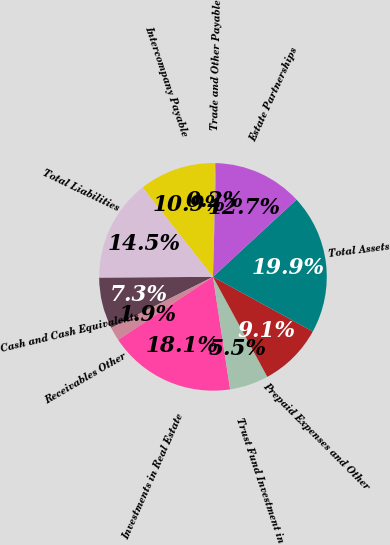Convert chart. <chart><loc_0><loc_0><loc_500><loc_500><pie_chart><fcel>Cash and Cash Equivalents<fcel>Receivables Other<fcel>Investments in Real Estate<fcel>Trust Fund Investment in<fcel>Prepaid Expenses and Other<fcel>Total Assets<fcel>Estate Partnerships<fcel>Trade and Other Payable<fcel>Intercompany Payable<fcel>Total Liabilities<nl><fcel>7.31%<fcel>1.94%<fcel>18.06%<fcel>5.52%<fcel>9.1%<fcel>19.85%<fcel>12.69%<fcel>0.15%<fcel>10.9%<fcel>14.48%<nl></chart> 